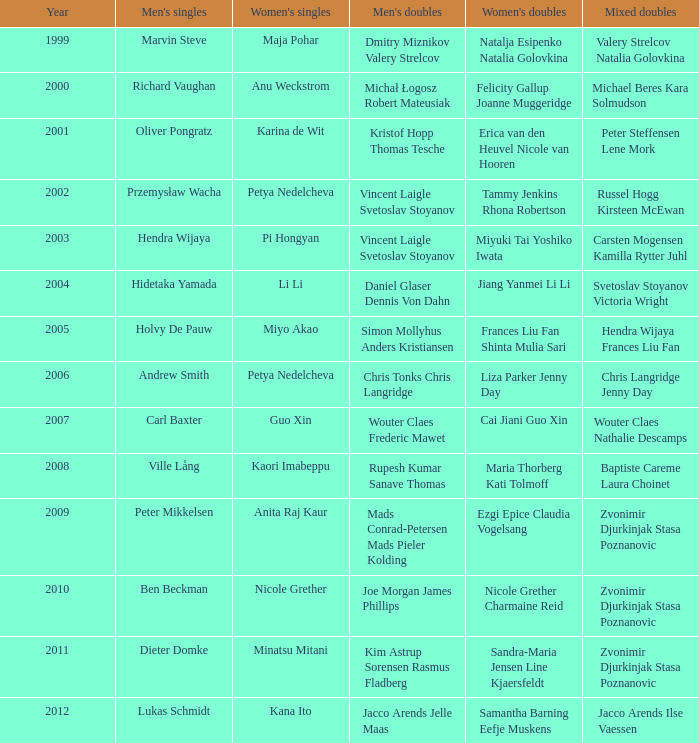What was the initial year pi hongyan participated in women's singles? 2003.0. 